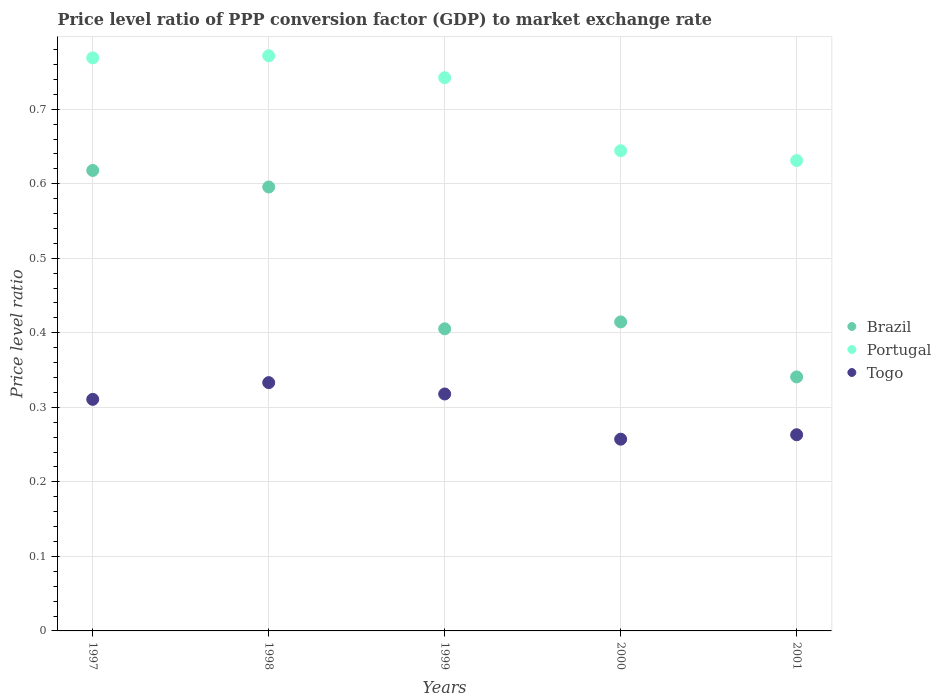Is the number of dotlines equal to the number of legend labels?
Give a very brief answer. Yes. What is the price level ratio in Brazil in 2000?
Offer a terse response. 0.41. Across all years, what is the maximum price level ratio in Brazil?
Your response must be concise. 0.62. Across all years, what is the minimum price level ratio in Portugal?
Offer a terse response. 0.63. What is the total price level ratio in Portugal in the graph?
Provide a short and direct response. 3.56. What is the difference between the price level ratio in Portugal in 1998 and that in 1999?
Offer a very short reply. 0.03. What is the difference between the price level ratio in Brazil in 1998 and the price level ratio in Togo in 2000?
Offer a terse response. 0.34. What is the average price level ratio in Portugal per year?
Offer a terse response. 0.71. In the year 1999, what is the difference between the price level ratio in Togo and price level ratio in Portugal?
Your answer should be very brief. -0.42. In how many years, is the price level ratio in Brazil greater than 0.6200000000000001?
Offer a very short reply. 0. What is the ratio of the price level ratio in Togo in 1998 to that in 1999?
Your answer should be very brief. 1.05. Is the price level ratio in Brazil in 1998 less than that in 2000?
Provide a short and direct response. No. What is the difference between the highest and the second highest price level ratio in Brazil?
Offer a terse response. 0.02. What is the difference between the highest and the lowest price level ratio in Portugal?
Your answer should be compact. 0.14. Is it the case that in every year, the sum of the price level ratio in Brazil and price level ratio in Portugal  is greater than the price level ratio in Togo?
Keep it short and to the point. Yes. Does the price level ratio in Brazil monotonically increase over the years?
Offer a terse response. No. Is the price level ratio in Togo strictly greater than the price level ratio in Portugal over the years?
Your answer should be compact. No. Is the price level ratio in Togo strictly less than the price level ratio in Brazil over the years?
Your answer should be very brief. Yes. How many years are there in the graph?
Keep it short and to the point. 5. How are the legend labels stacked?
Provide a short and direct response. Vertical. What is the title of the graph?
Your response must be concise. Price level ratio of PPP conversion factor (GDP) to market exchange rate. Does "Israel" appear as one of the legend labels in the graph?
Provide a short and direct response. No. What is the label or title of the Y-axis?
Your answer should be very brief. Price level ratio. What is the Price level ratio in Brazil in 1997?
Your response must be concise. 0.62. What is the Price level ratio of Portugal in 1997?
Ensure brevity in your answer.  0.77. What is the Price level ratio of Togo in 1997?
Ensure brevity in your answer.  0.31. What is the Price level ratio of Brazil in 1998?
Your response must be concise. 0.6. What is the Price level ratio of Portugal in 1998?
Your answer should be compact. 0.77. What is the Price level ratio in Togo in 1998?
Keep it short and to the point. 0.33. What is the Price level ratio in Brazil in 1999?
Keep it short and to the point. 0.41. What is the Price level ratio of Portugal in 1999?
Offer a very short reply. 0.74. What is the Price level ratio in Togo in 1999?
Ensure brevity in your answer.  0.32. What is the Price level ratio of Brazil in 2000?
Provide a succinct answer. 0.41. What is the Price level ratio of Portugal in 2000?
Provide a short and direct response. 0.64. What is the Price level ratio in Togo in 2000?
Offer a very short reply. 0.26. What is the Price level ratio of Brazil in 2001?
Your answer should be very brief. 0.34. What is the Price level ratio of Portugal in 2001?
Keep it short and to the point. 0.63. What is the Price level ratio in Togo in 2001?
Your answer should be very brief. 0.26. Across all years, what is the maximum Price level ratio of Brazil?
Ensure brevity in your answer.  0.62. Across all years, what is the maximum Price level ratio of Portugal?
Offer a very short reply. 0.77. Across all years, what is the maximum Price level ratio in Togo?
Offer a terse response. 0.33. Across all years, what is the minimum Price level ratio in Brazil?
Make the answer very short. 0.34. Across all years, what is the minimum Price level ratio of Portugal?
Offer a very short reply. 0.63. Across all years, what is the minimum Price level ratio in Togo?
Give a very brief answer. 0.26. What is the total Price level ratio in Brazil in the graph?
Your answer should be compact. 2.37. What is the total Price level ratio of Portugal in the graph?
Your answer should be compact. 3.56. What is the total Price level ratio of Togo in the graph?
Give a very brief answer. 1.48. What is the difference between the Price level ratio of Brazil in 1997 and that in 1998?
Your answer should be compact. 0.02. What is the difference between the Price level ratio of Portugal in 1997 and that in 1998?
Ensure brevity in your answer.  -0. What is the difference between the Price level ratio in Togo in 1997 and that in 1998?
Provide a succinct answer. -0.02. What is the difference between the Price level ratio of Brazil in 1997 and that in 1999?
Offer a very short reply. 0.21. What is the difference between the Price level ratio in Portugal in 1997 and that in 1999?
Your answer should be very brief. 0.03. What is the difference between the Price level ratio of Togo in 1997 and that in 1999?
Make the answer very short. -0.01. What is the difference between the Price level ratio in Brazil in 1997 and that in 2000?
Your answer should be compact. 0.2. What is the difference between the Price level ratio of Portugal in 1997 and that in 2000?
Keep it short and to the point. 0.12. What is the difference between the Price level ratio in Togo in 1997 and that in 2000?
Provide a succinct answer. 0.05. What is the difference between the Price level ratio in Brazil in 1997 and that in 2001?
Your response must be concise. 0.28. What is the difference between the Price level ratio in Portugal in 1997 and that in 2001?
Offer a very short reply. 0.14. What is the difference between the Price level ratio in Togo in 1997 and that in 2001?
Provide a succinct answer. 0.05. What is the difference between the Price level ratio of Brazil in 1998 and that in 1999?
Make the answer very short. 0.19. What is the difference between the Price level ratio of Portugal in 1998 and that in 1999?
Your answer should be compact. 0.03. What is the difference between the Price level ratio of Togo in 1998 and that in 1999?
Your answer should be compact. 0.02. What is the difference between the Price level ratio in Brazil in 1998 and that in 2000?
Make the answer very short. 0.18. What is the difference between the Price level ratio of Portugal in 1998 and that in 2000?
Provide a short and direct response. 0.13. What is the difference between the Price level ratio of Togo in 1998 and that in 2000?
Your response must be concise. 0.08. What is the difference between the Price level ratio in Brazil in 1998 and that in 2001?
Your answer should be compact. 0.25. What is the difference between the Price level ratio of Portugal in 1998 and that in 2001?
Provide a succinct answer. 0.14. What is the difference between the Price level ratio in Togo in 1998 and that in 2001?
Ensure brevity in your answer.  0.07. What is the difference between the Price level ratio of Brazil in 1999 and that in 2000?
Your answer should be very brief. -0.01. What is the difference between the Price level ratio in Portugal in 1999 and that in 2000?
Give a very brief answer. 0.1. What is the difference between the Price level ratio of Togo in 1999 and that in 2000?
Your response must be concise. 0.06. What is the difference between the Price level ratio in Brazil in 1999 and that in 2001?
Ensure brevity in your answer.  0.06. What is the difference between the Price level ratio of Portugal in 1999 and that in 2001?
Your response must be concise. 0.11. What is the difference between the Price level ratio of Togo in 1999 and that in 2001?
Make the answer very short. 0.05. What is the difference between the Price level ratio in Brazil in 2000 and that in 2001?
Provide a succinct answer. 0.07. What is the difference between the Price level ratio in Portugal in 2000 and that in 2001?
Give a very brief answer. 0.01. What is the difference between the Price level ratio of Togo in 2000 and that in 2001?
Your answer should be compact. -0.01. What is the difference between the Price level ratio in Brazil in 1997 and the Price level ratio in Portugal in 1998?
Make the answer very short. -0.15. What is the difference between the Price level ratio of Brazil in 1997 and the Price level ratio of Togo in 1998?
Keep it short and to the point. 0.28. What is the difference between the Price level ratio in Portugal in 1997 and the Price level ratio in Togo in 1998?
Make the answer very short. 0.44. What is the difference between the Price level ratio of Brazil in 1997 and the Price level ratio of Portugal in 1999?
Your answer should be very brief. -0.12. What is the difference between the Price level ratio of Brazil in 1997 and the Price level ratio of Togo in 1999?
Provide a succinct answer. 0.3. What is the difference between the Price level ratio of Portugal in 1997 and the Price level ratio of Togo in 1999?
Your answer should be very brief. 0.45. What is the difference between the Price level ratio in Brazil in 1997 and the Price level ratio in Portugal in 2000?
Your response must be concise. -0.03. What is the difference between the Price level ratio of Brazil in 1997 and the Price level ratio of Togo in 2000?
Offer a terse response. 0.36. What is the difference between the Price level ratio in Portugal in 1997 and the Price level ratio in Togo in 2000?
Offer a very short reply. 0.51. What is the difference between the Price level ratio of Brazil in 1997 and the Price level ratio of Portugal in 2001?
Your answer should be very brief. -0.01. What is the difference between the Price level ratio of Brazil in 1997 and the Price level ratio of Togo in 2001?
Ensure brevity in your answer.  0.35. What is the difference between the Price level ratio in Portugal in 1997 and the Price level ratio in Togo in 2001?
Make the answer very short. 0.51. What is the difference between the Price level ratio of Brazil in 1998 and the Price level ratio of Portugal in 1999?
Provide a succinct answer. -0.15. What is the difference between the Price level ratio in Brazil in 1998 and the Price level ratio in Togo in 1999?
Offer a terse response. 0.28. What is the difference between the Price level ratio of Portugal in 1998 and the Price level ratio of Togo in 1999?
Offer a terse response. 0.45. What is the difference between the Price level ratio in Brazil in 1998 and the Price level ratio in Portugal in 2000?
Make the answer very short. -0.05. What is the difference between the Price level ratio of Brazil in 1998 and the Price level ratio of Togo in 2000?
Your response must be concise. 0.34. What is the difference between the Price level ratio in Portugal in 1998 and the Price level ratio in Togo in 2000?
Your answer should be very brief. 0.51. What is the difference between the Price level ratio of Brazil in 1998 and the Price level ratio of Portugal in 2001?
Provide a short and direct response. -0.04. What is the difference between the Price level ratio of Brazil in 1998 and the Price level ratio of Togo in 2001?
Your answer should be very brief. 0.33. What is the difference between the Price level ratio in Portugal in 1998 and the Price level ratio in Togo in 2001?
Your response must be concise. 0.51. What is the difference between the Price level ratio of Brazil in 1999 and the Price level ratio of Portugal in 2000?
Provide a short and direct response. -0.24. What is the difference between the Price level ratio of Brazil in 1999 and the Price level ratio of Togo in 2000?
Make the answer very short. 0.15. What is the difference between the Price level ratio of Portugal in 1999 and the Price level ratio of Togo in 2000?
Give a very brief answer. 0.48. What is the difference between the Price level ratio in Brazil in 1999 and the Price level ratio in Portugal in 2001?
Ensure brevity in your answer.  -0.23. What is the difference between the Price level ratio in Brazil in 1999 and the Price level ratio in Togo in 2001?
Your answer should be compact. 0.14. What is the difference between the Price level ratio in Portugal in 1999 and the Price level ratio in Togo in 2001?
Make the answer very short. 0.48. What is the difference between the Price level ratio of Brazil in 2000 and the Price level ratio of Portugal in 2001?
Provide a short and direct response. -0.22. What is the difference between the Price level ratio in Brazil in 2000 and the Price level ratio in Togo in 2001?
Provide a succinct answer. 0.15. What is the difference between the Price level ratio of Portugal in 2000 and the Price level ratio of Togo in 2001?
Ensure brevity in your answer.  0.38. What is the average Price level ratio of Brazil per year?
Ensure brevity in your answer.  0.47. What is the average Price level ratio of Portugal per year?
Give a very brief answer. 0.71. What is the average Price level ratio in Togo per year?
Your response must be concise. 0.3. In the year 1997, what is the difference between the Price level ratio of Brazil and Price level ratio of Portugal?
Make the answer very short. -0.15. In the year 1997, what is the difference between the Price level ratio in Brazil and Price level ratio in Togo?
Your answer should be very brief. 0.31. In the year 1997, what is the difference between the Price level ratio in Portugal and Price level ratio in Togo?
Ensure brevity in your answer.  0.46. In the year 1998, what is the difference between the Price level ratio in Brazil and Price level ratio in Portugal?
Offer a terse response. -0.18. In the year 1998, what is the difference between the Price level ratio in Brazil and Price level ratio in Togo?
Keep it short and to the point. 0.26. In the year 1998, what is the difference between the Price level ratio of Portugal and Price level ratio of Togo?
Make the answer very short. 0.44. In the year 1999, what is the difference between the Price level ratio of Brazil and Price level ratio of Portugal?
Offer a terse response. -0.34. In the year 1999, what is the difference between the Price level ratio of Brazil and Price level ratio of Togo?
Your response must be concise. 0.09. In the year 1999, what is the difference between the Price level ratio of Portugal and Price level ratio of Togo?
Provide a short and direct response. 0.42. In the year 2000, what is the difference between the Price level ratio in Brazil and Price level ratio in Portugal?
Keep it short and to the point. -0.23. In the year 2000, what is the difference between the Price level ratio of Brazil and Price level ratio of Togo?
Provide a succinct answer. 0.16. In the year 2000, what is the difference between the Price level ratio in Portugal and Price level ratio in Togo?
Provide a short and direct response. 0.39. In the year 2001, what is the difference between the Price level ratio in Brazil and Price level ratio in Portugal?
Ensure brevity in your answer.  -0.29. In the year 2001, what is the difference between the Price level ratio of Brazil and Price level ratio of Togo?
Offer a terse response. 0.08. In the year 2001, what is the difference between the Price level ratio of Portugal and Price level ratio of Togo?
Give a very brief answer. 0.37. What is the ratio of the Price level ratio in Brazil in 1997 to that in 1998?
Make the answer very short. 1.04. What is the ratio of the Price level ratio of Togo in 1997 to that in 1998?
Your answer should be compact. 0.93. What is the ratio of the Price level ratio in Brazil in 1997 to that in 1999?
Your answer should be very brief. 1.52. What is the ratio of the Price level ratio of Portugal in 1997 to that in 1999?
Your response must be concise. 1.04. What is the ratio of the Price level ratio of Togo in 1997 to that in 1999?
Your response must be concise. 0.98. What is the ratio of the Price level ratio in Brazil in 1997 to that in 2000?
Your answer should be compact. 1.49. What is the ratio of the Price level ratio of Portugal in 1997 to that in 2000?
Give a very brief answer. 1.19. What is the ratio of the Price level ratio of Togo in 1997 to that in 2000?
Keep it short and to the point. 1.21. What is the ratio of the Price level ratio in Brazil in 1997 to that in 2001?
Provide a short and direct response. 1.81. What is the ratio of the Price level ratio in Portugal in 1997 to that in 2001?
Provide a succinct answer. 1.22. What is the ratio of the Price level ratio of Togo in 1997 to that in 2001?
Ensure brevity in your answer.  1.18. What is the ratio of the Price level ratio of Brazil in 1998 to that in 1999?
Provide a succinct answer. 1.47. What is the ratio of the Price level ratio in Portugal in 1998 to that in 1999?
Your response must be concise. 1.04. What is the ratio of the Price level ratio of Togo in 1998 to that in 1999?
Keep it short and to the point. 1.05. What is the ratio of the Price level ratio of Brazil in 1998 to that in 2000?
Keep it short and to the point. 1.44. What is the ratio of the Price level ratio of Portugal in 1998 to that in 2000?
Your answer should be very brief. 1.2. What is the ratio of the Price level ratio in Togo in 1998 to that in 2000?
Your answer should be very brief. 1.29. What is the ratio of the Price level ratio of Brazil in 1998 to that in 2001?
Ensure brevity in your answer.  1.75. What is the ratio of the Price level ratio of Portugal in 1998 to that in 2001?
Offer a terse response. 1.22. What is the ratio of the Price level ratio of Togo in 1998 to that in 2001?
Your answer should be compact. 1.27. What is the ratio of the Price level ratio in Brazil in 1999 to that in 2000?
Offer a very short reply. 0.98. What is the ratio of the Price level ratio of Portugal in 1999 to that in 2000?
Make the answer very short. 1.15. What is the ratio of the Price level ratio in Togo in 1999 to that in 2000?
Ensure brevity in your answer.  1.24. What is the ratio of the Price level ratio in Brazil in 1999 to that in 2001?
Give a very brief answer. 1.19. What is the ratio of the Price level ratio of Portugal in 1999 to that in 2001?
Provide a succinct answer. 1.18. What is the ratio of the Price level ratio of Togo in 1999 to that in 2001?
Ensure brevity in your answer.  1.21. What is the ratio of the Price level ratio of Brazil in 2000 to that in 2001?
Offer a terse response. 1.22. What is the ratio of the Price level ratio in Portugal in 2000 to that in 2001?
Offer a very short reply. 1.02. What is the ratio of the Price level ratio in Togo in 2000 to that in 2001?
Provide a short and direct response. 0.98. What is the difference between the highest and the second highest Price level ratio in Brazil?
Provide a succinct answer. 0.02. What is the difference between the highest and the second highest Price level ratio of Portugal?
Give a very brief answer. 0. What is the difference between the highest and the second highest Price level ratio in Togo?
Make the answer very short. 0.02. What is the difference between the highest and the lowest Price level ratio in Brazil?
Your answer should be very brief. 0.28. What is the difference between the highest and the lowest Price level ratio in Portugal?
Give a very brief answer. 0.14. What is the difference between the highest and the lowest Price level ratio of Togo?
Give a very brief answer. 0.08. 